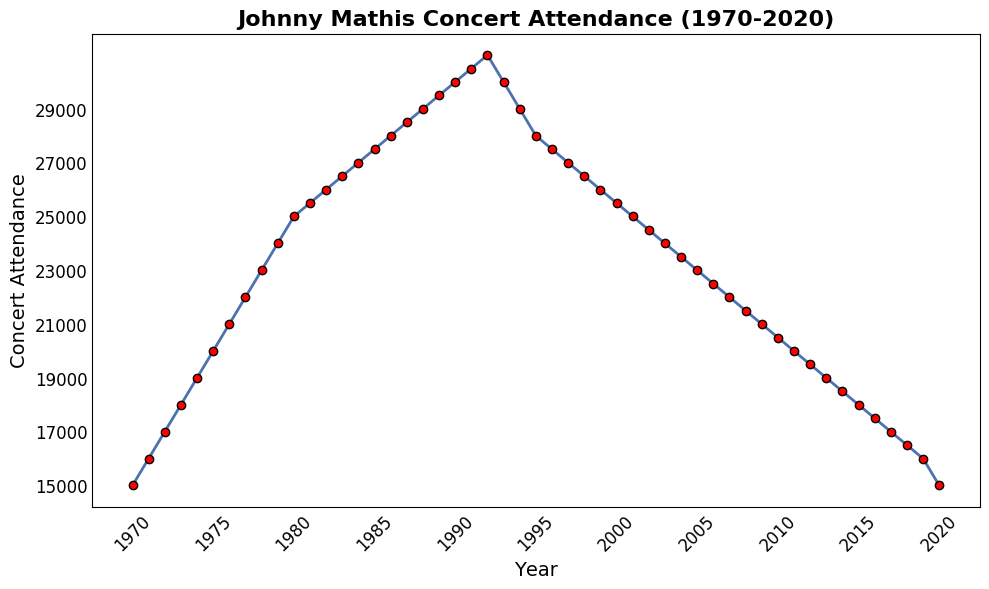What is the concert attendance in the year 1985? To find the concert attendance for 1985, locate the year 1985 on the x-axis and trace upwards to the corresponding point on the graph. Read the y-axis value at that point, which is labeled "27,500".
Answer: 27,500 How did the concert attendance change from 1970 to 1990? To determine the change, subtract the attendance in 1970 from the attendance in 1990. In 1970, the attendance was 15,000. In 1990, it was 30,000. The change is 30,000 - 15,000.
Answer: Increased by 15,000 What is the period with the highest concert attendance? Scan the plot to find the highest point on the y-axis. The highest concert attendance is 31,000 which occurs in the year 1992.
Answer: 1992 Between which years did the concert attendance experience the most significant drop? To find the steepest decline, compare the differences in attendance between consecutive years. The most significant drop occurs between 1992 and 1994, where attendance fell from 31,000 to 29,000, a drop of 2,000.
Answer: 1992 to 1994 What is the median concert attendance value over the years? To find the median, list all attendance figures in ascending order and find the middle value. With 51 data points, the median is the value in the 26th position. The attendance figure at the 26th position (median) is 27,500.
Answer: 27,500 Describe the overall trend of Johnny Mathis' concert attendance from 1970 to 2020. The plot shows an initial consistent increase in attendance from 1970 to 1992, peaking at 31,000. After 1992, attendance steadily declines.
Answer: Rising then Falling What are the years where attendance was exactly 25,000? From the plot, identify the years where the y-axis value intersects 25,000. Attendance was 25,000 in the years 1980 and 2001.
Answer: 1980 and 2001 By how much did concert attendance change between 2000 and 2010? Locate the attendance figures for 2000 and 2010. In 2000, it was 25,500 and in 2010, it was 20,500. Subtract to find the difference: 25,500 - 20,500.
Answer: Decreased by 5,000 Which year had a higher concert attendance: 1988 or 2005? Compare the attendance figures for 1988 and 2005. In 1988, it was 29,000, and in 2005, it was 23,000. 29,000 is greater than 23,000.
Answer: 1988 How many years did it take for the concert attendance to double from the starting value in 1970? The starting value in 1970 was 15,000. Double 15,000 is 30,000. Locate the year when the attendance reached 30,000, which is 1990. The number of years taken is 1990 - 1970.
Answer: 20 years How does the attendance in 2020 compare to the starting year, 1970? Locate the attendance values for 1970 and 2020. Both years have an attendance of 15,000, implying no change over this time period.
Answer: No change 